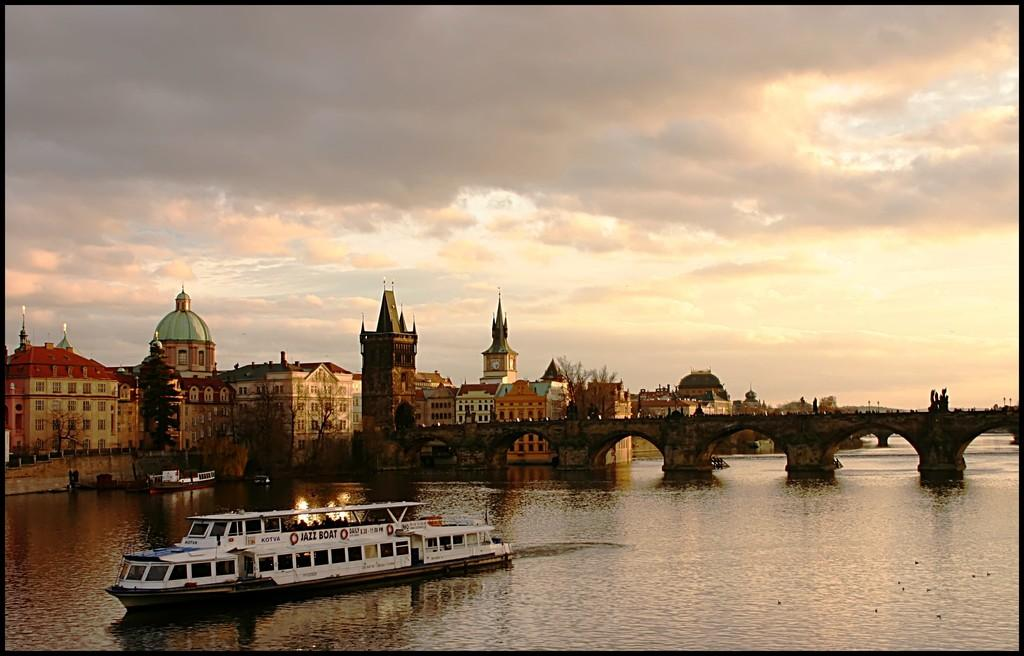What types of watercraft are present in the image? There are ships and boats on the water body in the image. What structure can be seen crossing the water body? There is a bridge in the image. What can be seen in the background of the image? There are buildings and trees in the background of the image. How would you describe the sky in the image? The sky is cloudy in the image. What type of ghost can be seen haunting the ships in the image? There are no ghosts present in the image; it features ships, boats, a bridge, buildings, trees, and a cloudy sky. What type of army is visible marching across the bridge in the image? There is no army present in the image; it features ships, boats, a bridge, buildings, trees, and a cloudy sky. 